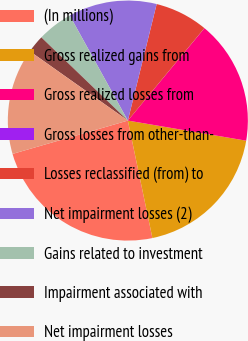Convert chart. <chart><loc_0><loc_0><loc_500><loc_500><pie_chart><fcel>(In millions)<fcel>Gross realized gains from<fcel>Gross realized losses from<fcel>Gross losses from other-than-<fcel>Losses reclassified (from) to<fcel>Net impairment losses (2)<fcel>Gains related to investment<fcel>Impairment associated with<fcel>Net impairment losses<nl><fcel>23.8%<fcel>19.04%<fcel>16.66%<fcel>0.01%<fcel>7.15%<fcel>11.9%<fcel>4.77%<fcel>2.39%<fcel>14.28%<nl></chart> 